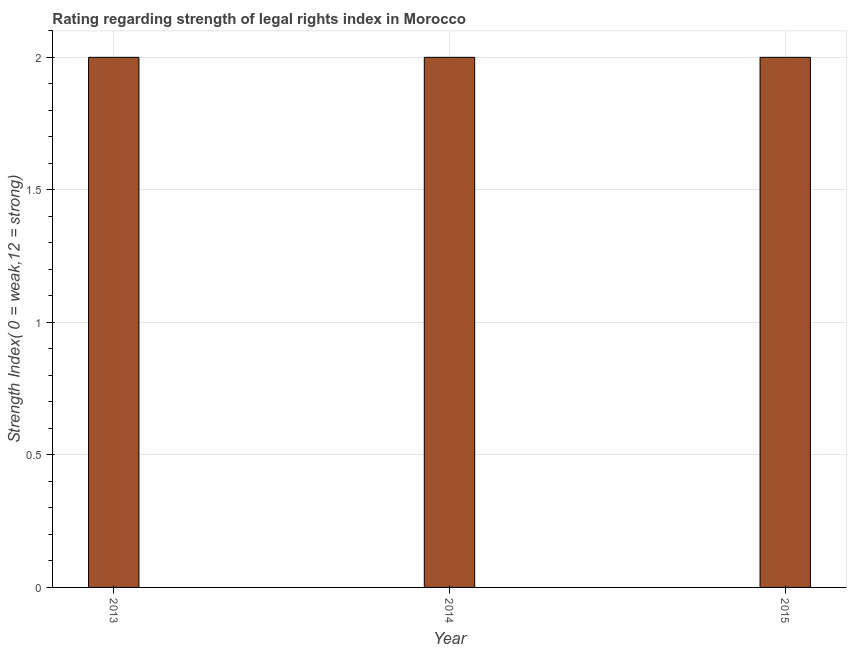What is the title of the graph?
Provide a short and direct response. Rating regarding strength of legal rights index in Morocco. What is the label or title of the X-axis?
Your response must be concise. Year. What is the label or title of the Y-axis?
Offer a very short reply. Strength Index( 0 = weak,12 = strong). What is the sum of the strength of legal rights index?
Make the answer very short. 6. What is the difference between the strength of legal rights index in 2013 and 2014?
Provide a succinct answer. 0. What is the average strength of legal rights index per year?
Keep it short and to the point. 2. In how many years, is the strength of legal rights index greater than 0.1 ?
Provide a short and direct response. 3. Do a majority of the years between 2014 and 2013 (inclusive) have strength of legal rights index greater than 1.8 ?
Your response must be concise. No. What is the ratio of the strength of legal rights index in 2013 to that in 2015?
Offer a very short reply. 1. Is the strength of legal rights index in 2013 less than that in 2014?
Ensure brevity in your answer.  No. Is the sum of the strength of legal rights index in 2013 and 2014 greater than the maximum strength of legal rights index across all years?
Offer a terse response. Yes. What is the difference between the highest and the lowest strength of legal rights index?
Ensure brevity in your answer.  0. How many bars are there?
Your response must be concise. 3. Are all the bars in the graph horizontal?
Provide a succinct answer. No. Are the values on the major ticks of Y-axis written in scientific E-notation?
Provide a short and direct response. No. What is the Strength Index( 0 = weak,12 = strong) in 2013?
Make the answer very short. 2. What is the Strength Index( 0 = weak,12 = strong) in 2014?
Offer a very short reply. 2. What is the Strength Index( 0 = weak,12 = strong) of 2015?
Your answer should be very brief. 2. What is the difference between the Strength Index( 0 = weak,12 = strong) in 2013 and 2014?
Your response must be concise. 0. What is the ratio of the Strength Index( 0 = weak,12 = strong) in 2013 to that in 2015?
Keep it short and to the point. 1. What is the ratio of the Strength Index( 0 = weak,12 = strong) in 2014 to that in 2015?
Your answer should be very brief. 1. 